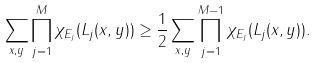<formula> <loc_0><loc_0><loc_500><loc_500>\sum _ { x , y } \prod _ { j = 1 } ^ { M } \chi _ { E _ { j } } ( L _ { j } ( x , y ) ) \geq \frac { 1 } { 2 } \sum _ { x , y } \prod _ { j = 1 } ^ { M - 1 } \chi _ { E _ { j } } ( L _ { j } ( x , y ) ) .</formula> 